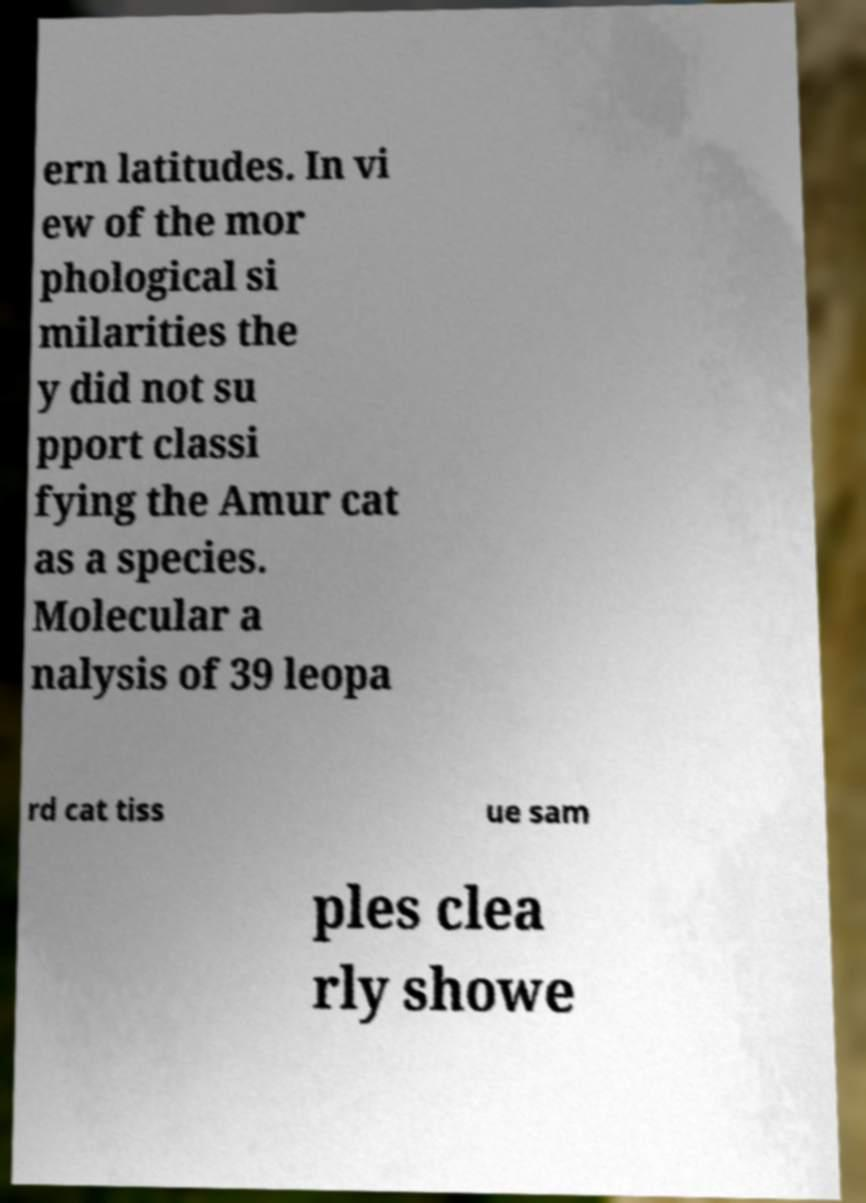Please read and relay the text visible in this image. What does it say? ern latitudes. In vi ew of the mor phological si milarities the y did not su pport classi fying the Amur cat as a species. Molecular a nalysis of 39 leopa rd cat tiss ue sam ples clea rly showe 